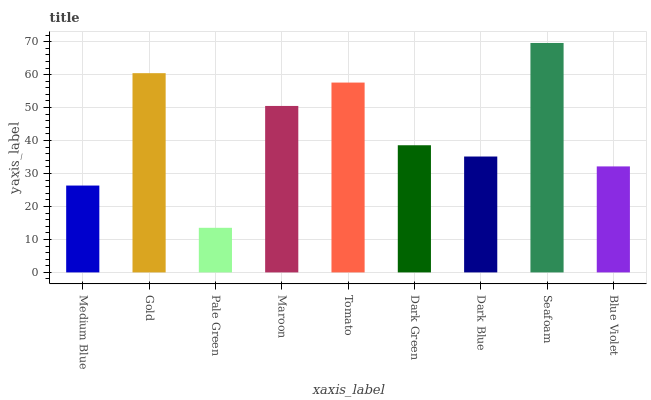Is Pale Green the minimum?
Answer yes or no. Yes. Is Seafoam the maximum?
Answer yes or no. Yes. Is Gold the minimum?
Answer yes or no. No. Is Gold the maximum?
Answer yes or no. No. Is Gold greater than Medium Blue?
Answer yes or no. Yes. Is Medium Blue less than Gold?
Answer yes or no. Yes. Is Medium Blue greater than Gold?
Answer yes or no. No. Is Gold less than Medium Blue?
Answer yes or no. No. Is Dark Green the high median?
Answer yes or no. Yes. Is Dark Green the low median?
Answer yes or no. Yes. Is Tomato the high median?
Answer yes or no. No. Is Dark Blue the low median?
Answer yes or no. No. 